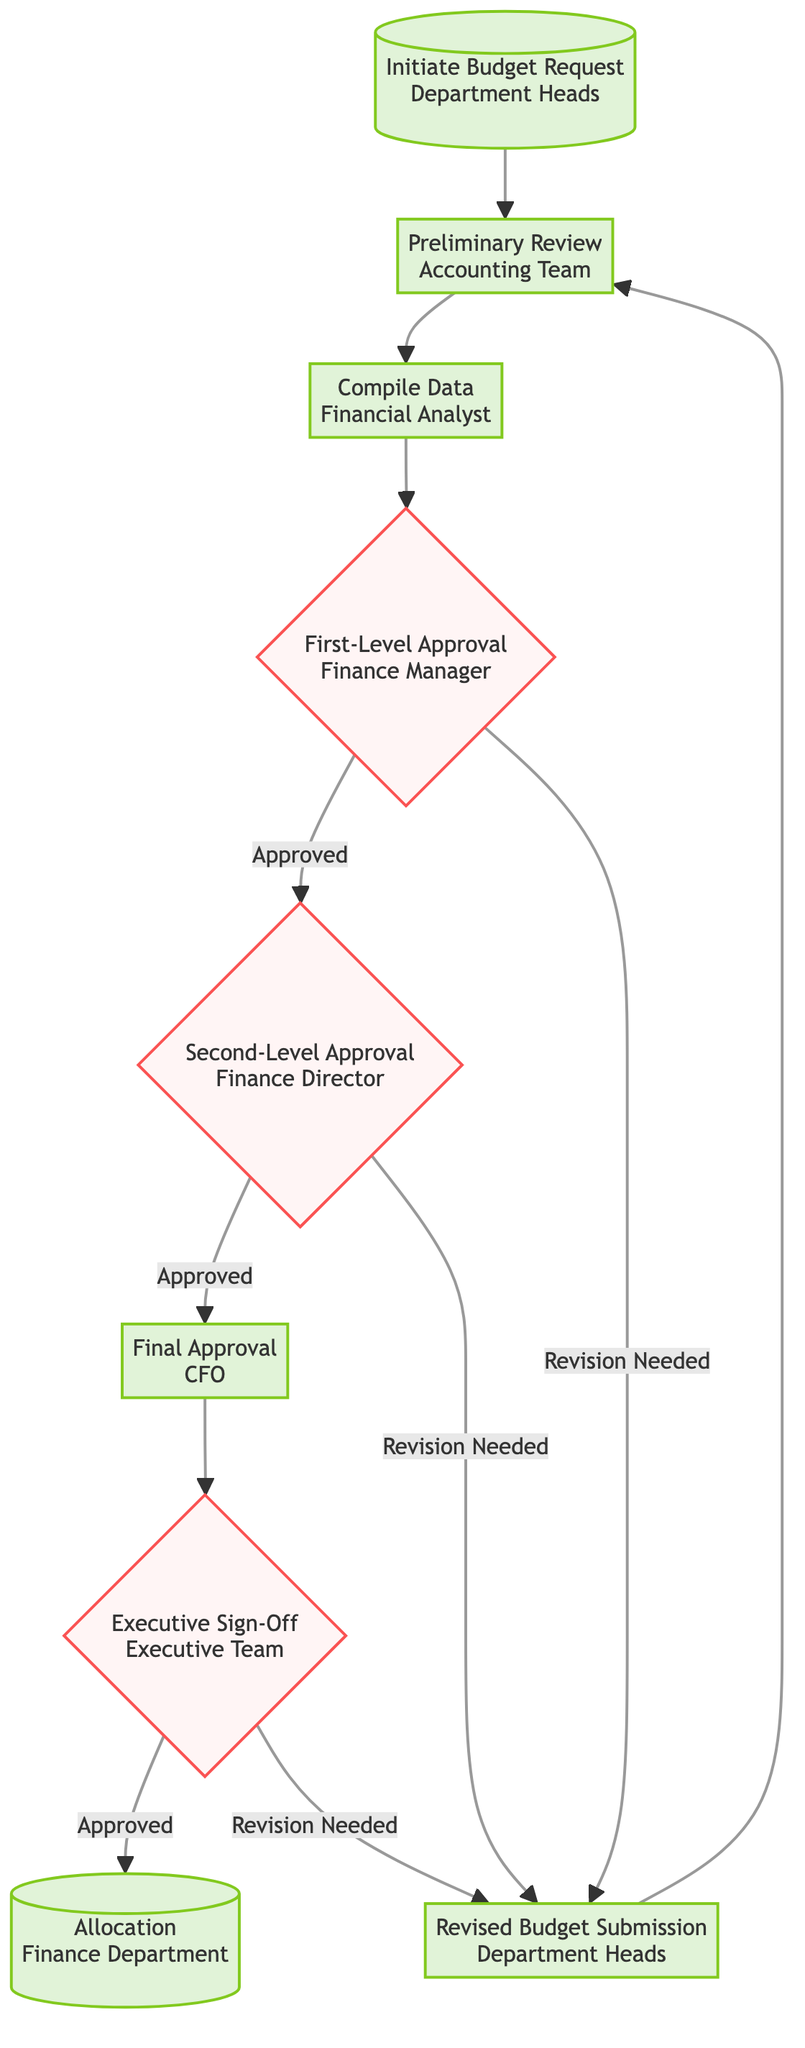What is the first step in the budget approval workflow? The first step is "Initiate Budget Request," where department heads submit initial budget requests for defense projects.
Answer: Initiate Budget Request Who performs the preliminary review of the budget requests? The preliminary review is performed by the "Accounting Team."
Answer: Accounting Team What happens after the "Preliminary Review"? After the "Preliminary Review," the next step is "Compile Data," where financial data is compiled into a comprehensive budget proposal.
Answer: Compile Data How many levels of approval are there in the workflow? There are two levels of approval in the workflow, which are "First-Level Approval" and "Second-Level Approval."
Answer: Two What happens if the first-level approval is not granted? If the first-level approval is not granted, the budget proposal is sent back for revision, leading to the "Revised Budget Submission."
Answer: Revision Needed What is the final step in the budget approval workflow? The final step is "Allocation," where the approved budget is allocated to respective departments for execution of defense projects.
Answer: Allocation What role does the CFO play in this workflow? The CFO is responsible for "Final Approval," where the approved budget is reviewed and finalized before seeking executive sign-off.
Answer: Final Approval What occurs if the executive sign-off is not granted? If the executive sign-off is not granted, the proposals must return to the "Revised Budget Submission" step for further revisions.
Answer: Revision Needed Which entity is responsible for allocating the approved budget? The "Finance Department" is responsible for allocating the approved budget to respective departments.
Answer: Finance Department 